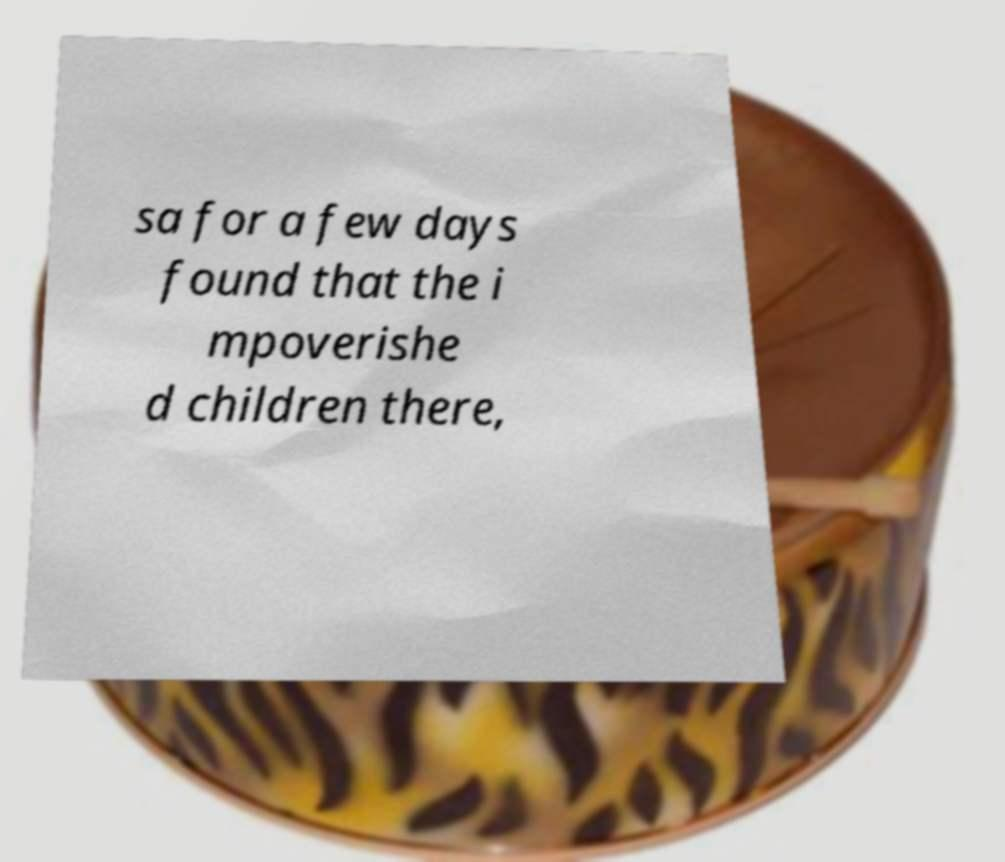Could you assist in decoding the text presented in this image and type it out clearly? sa for a few days found that the i mpoverishe d children there, 